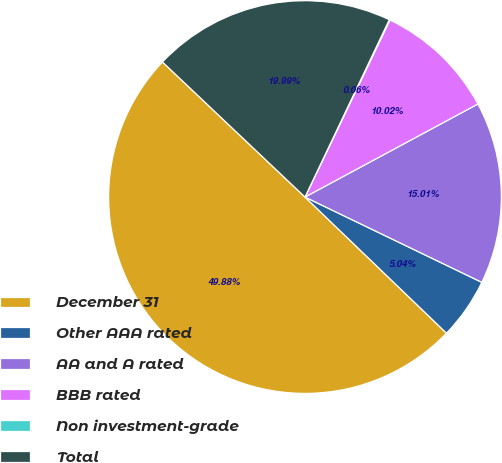Convert chart. <chart><loc_0><loc_0><loc_500><loc_500><pie_chart><fcel>December 31<fcel>Other AAA rated<fcel>AA and A rated<fcel>BBB rated<fcel>Non investment-grade<fcel>Total<nl><fcel>49.88%<fcel>5.04%<fcel>15.01%<fcel>10.02%<fcel>0.06%<fcel>19.99%<nl></chart> 